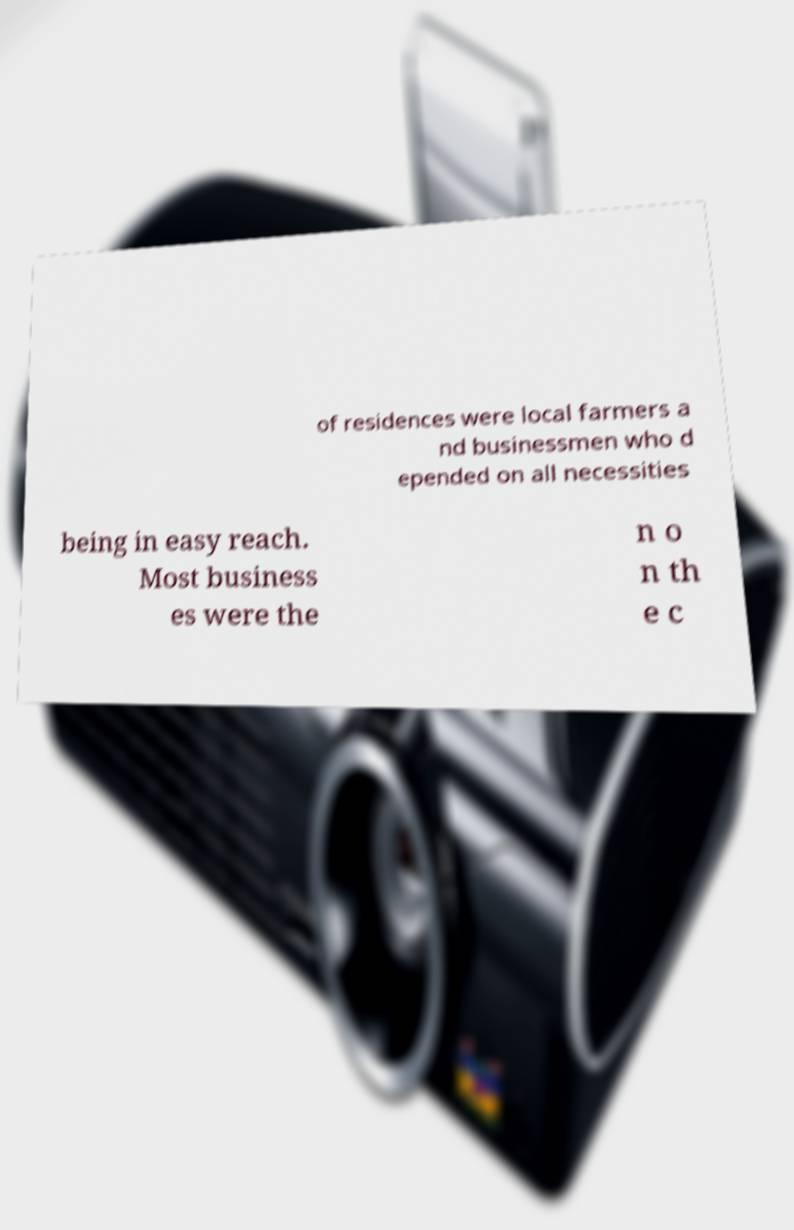Please identify and transcribe the text found in this image. of residences were local farmers a nd businessmen who d epended on all necessities being in easy reach. Most business es were the n o n th e c 